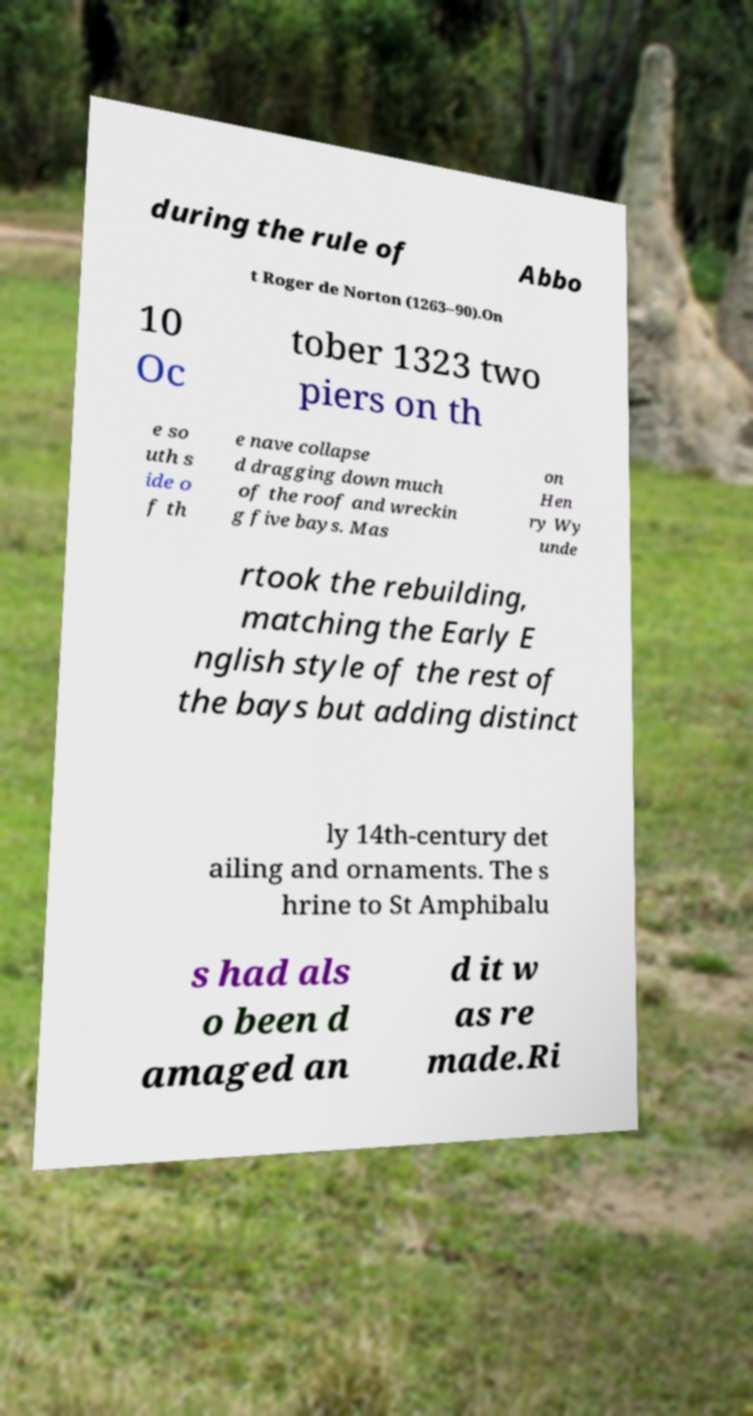I need the written content from this picture converted into text. Can you do that? during the rule of Abbo t Roger de Norton (1263–90).On 10 Oc tober 1323 two piers on th e so uth s ide o f th e nave collapse d dragging down much of the roof and wreckin g five bays. Mas on Hen ry Wy unde rtook the rebuilding, matching the Early E nglish style of the rest of the bays but adding distinct ly 14th-century det ailing and ornaments. The s hrine to St Amphibalu s had als o been d amaged an d it w as re made.Ri 